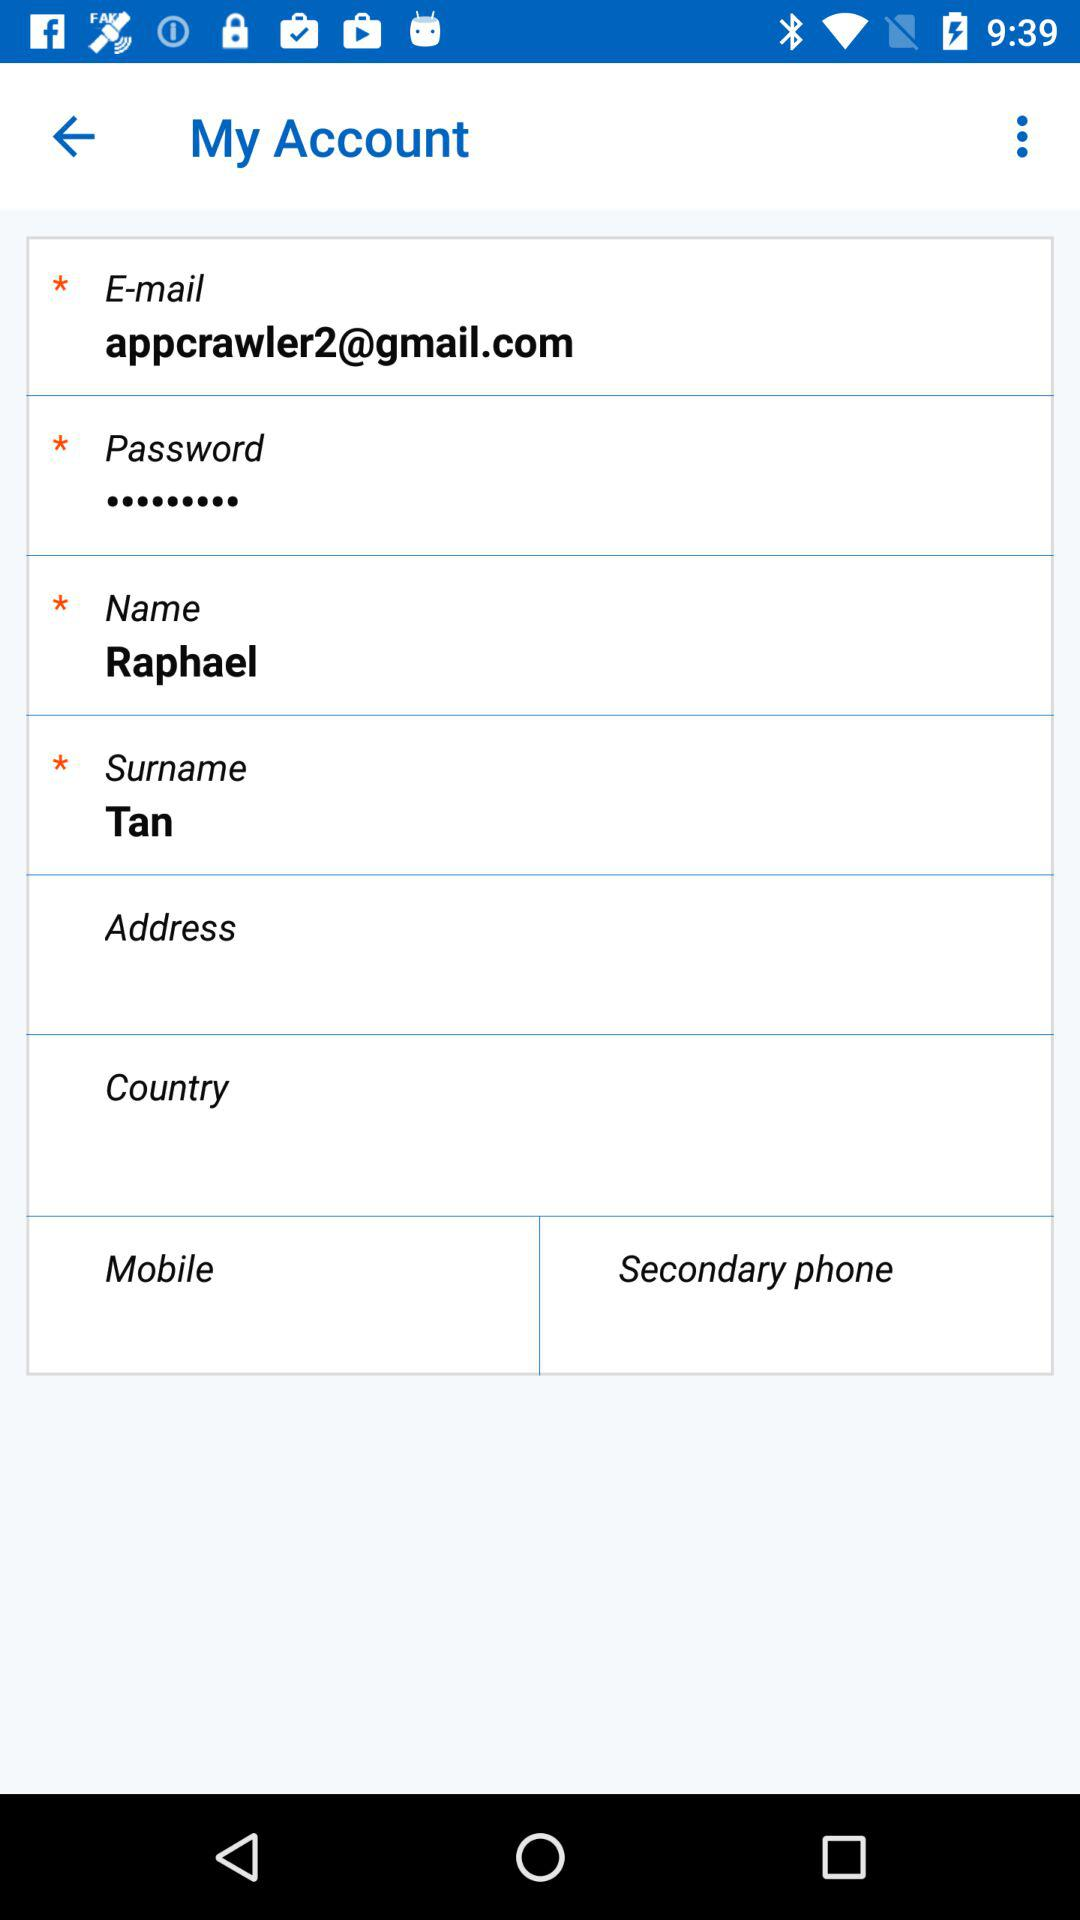What is the given email address? The given email address is appcrawler2@gmail.com. 